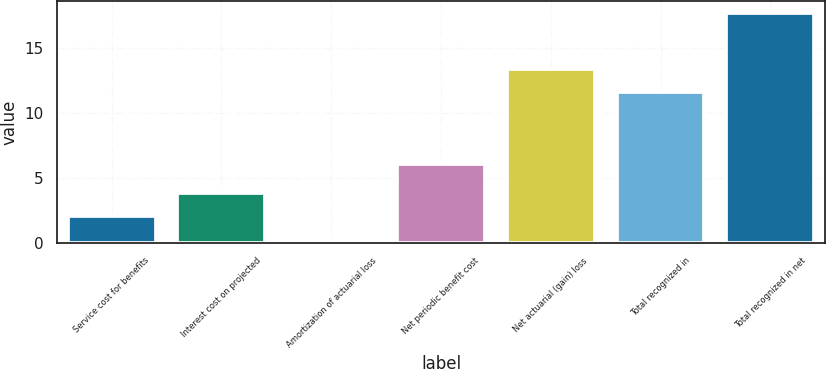Convert chart. <chart><loc_0><loc_0><loc_500><loc_500><bar_chart><fcel>Service cost for benefits<fcel>Interest cost on projected<fcel>Amortization of actuarial loss<fcel>Net periodic benefit cost<fcel>Net actuarial (gain) loss<fcel>Total recognized in<fcel>Total recognized in net<nl><fcel>2.1<fcel>3.85<fcel>0.2<fcel>6.1<fcel>13.35<fcel>11.6<fcel>17.7<nl></chart> 